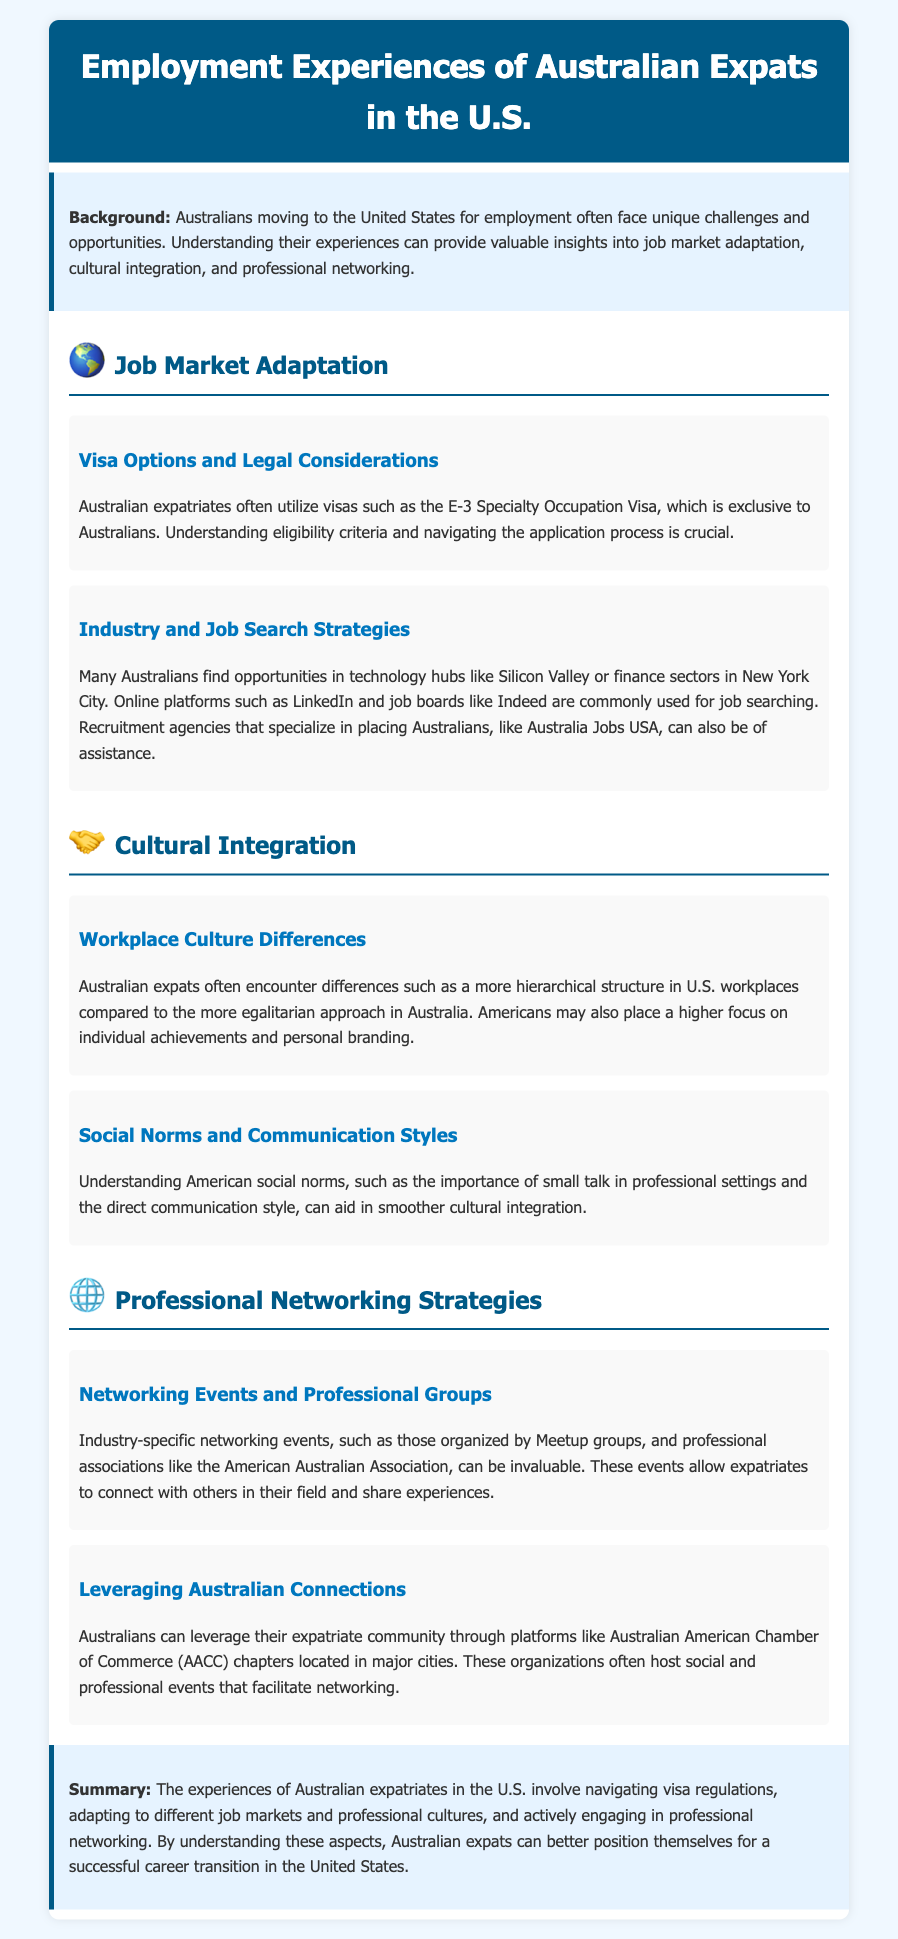What visa is commonly used by Australians in the U.S.? The E-3 Specialty Occupation Visa is specifically mentioned as a common visa used by Australians moving to the U.S.
Answer: E-3 Specialty Occupation Visa Which U.S. city is mentioned as a technology hub for Australian expats? Silicon Valley is highlighted as a technology hub where many Australians find job opportunities.
Answer: Silicon Valley What is a common job search platform mentioned in the document? The document specifies LinkedIn as one of the commonly used platforms for job searching.
Answer: LinkedIn What cultural aspect might Australian expats find different in U.S. workplaces? A more hierarchical structure in U.S. workplaces compared to Australia is pointed out as a cultural difference.
Answer: Hierarchical structure What importance does small talk have in U.S. professional settings? The document indicates that small talk is important in American social norms, especially in professional contexts.
Answer: Important Which organization hosts networking events for expatriates? The American Australian Association is listed as an organization that organizes networking events valuable for expatriates.
Answer: American Australian Association How do Australians leverage connections in the U.S.? Australians leverage their expatriate community through organizations like the Australian American Chamber of Commerce (AACC).
Answer: AACC What is a key aspect of successful career transition mentioned for Australian expats? The document highlights understanding visa regulations as a critical aspect of a successful career transition.
Answer: Understanding visa regulations 